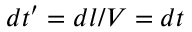Convert formula to latex. <formula><loc_0><loc_0><loc_500><loc_500>d t ^ { \prime } = d l / V = d t</formula> 